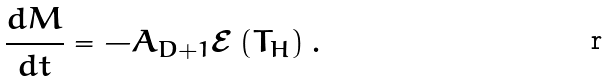Convert formula to latex. <formula><loc_0><loc_0><loc_500><loc_500>\frac { d M } { d t } = - A _ { D + 1 } { \mathcal { E } } \left ( T _ { H } \right ) .</formula> 